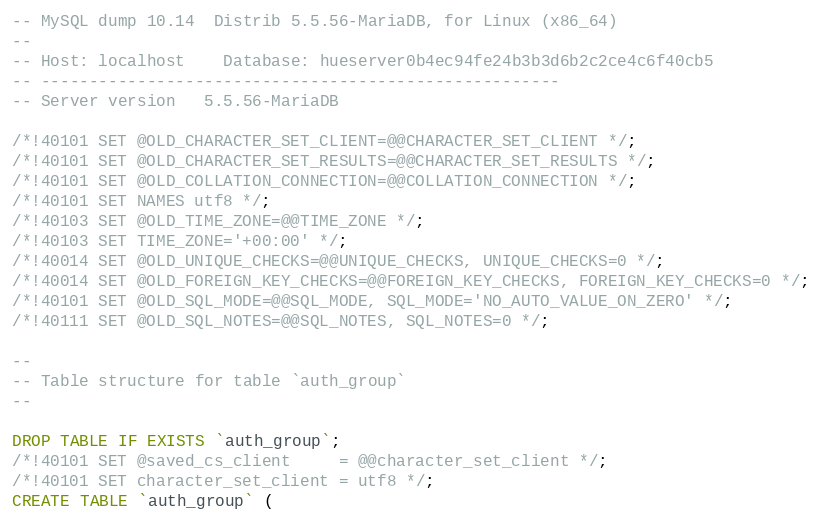Convert code to text. <code><loc_0><loc_0><loc_500><loc_500><_SQL_>-- MySQL dump 10.14  Distrib 5.5.56-MariaDB, for Linux (x86_64)
--
-- Host: localhost    Database: hueserver0b4ec94fe24b3b3d6b2c2ce4c6f40cb5
-- ------------------------------------------------------
-- Server version	5.5.56-MariaDB

/*!40101 SET @OLD_CHARACTER_SET_CLIENT=@@CHARACTER_SET_CLIENT */;
/*!40101 SET @OLD_CHARACTER_SET_RESULTS=@@CHARACTER_SET_RESULTS */;
/*!40101 SET @OLD_COLLATION_CONNECTION=@@COLLATION_CONNECTION */;
/*!40101 SET NAMES utf8 */;
/*!40103 SET @OLD_TIME_ZONE=@@TIME_ZONE */;
/*!40103 SET TIME_ZONE='+00:00' */;
/*!40014 SET @OLD_UNIQUE_CHECKS=@@UNIQUE_CHECKS, UNIQUE_CHECKS=0 */;
/*!40014 SET @OLD_FOREIGN_KEY_CHECKS=@@FOREIGN_KEY_CHECKS, FOREIGN_KEY_CHECKS=0 */;
/*!40101 SET @OLD_SQL_MODE=@@SQL_MODE, SQL_MODE='NO_AUTO_VALUE_ON_ZERO' */;
/*!40111 SET @OLD_SQL_NOTES=@@SQL_NOTES, SQL_NOTES=0 */;

--
-- Table structure for table `auth_group`
--

DROP TABLE IF EXISTS `auth_group`;
/*!40101 SET @saved_cs_client     = @@character_set_client */;
/*!40101 SET character_set_client = utf8 */;
CREATE TABLE `auth_group` (</code> 